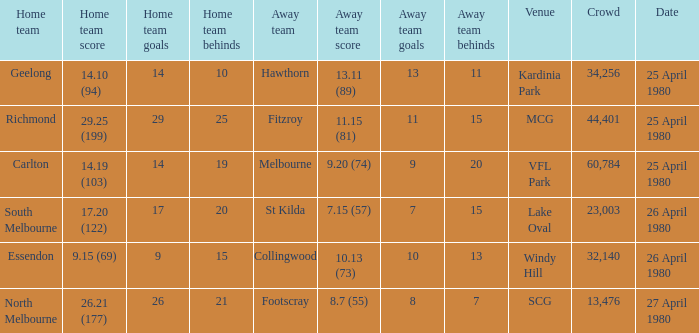On what date did the match at Lake Oval take place? 26 April 1980. 